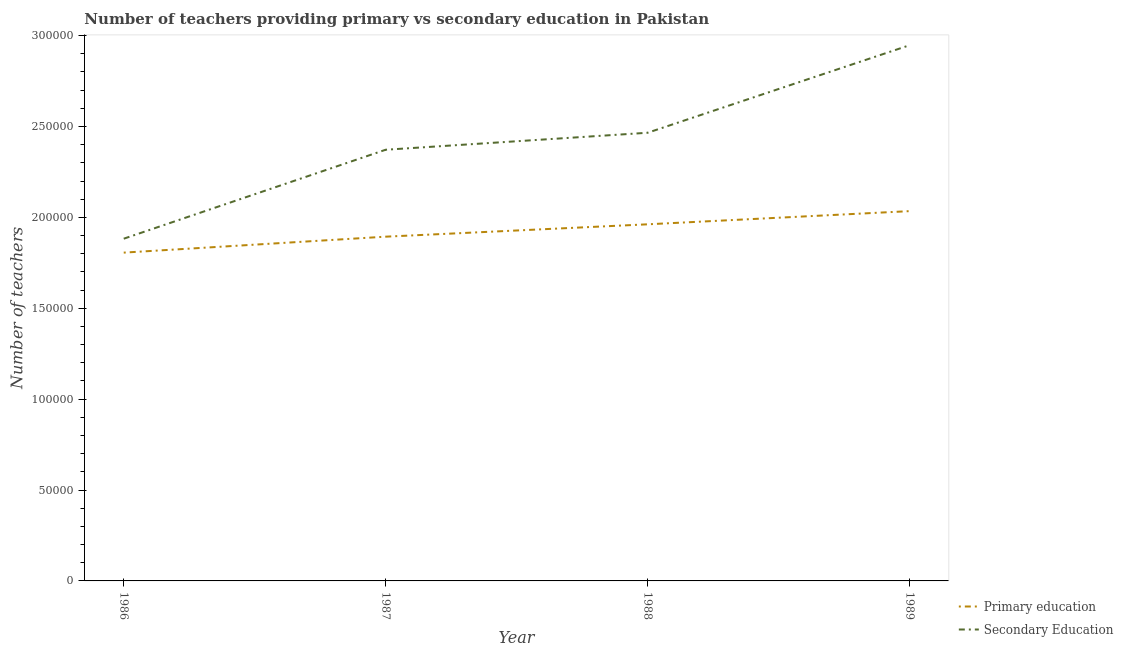What is the number of primary teachers in 1988?
Your answer should be very brief. 1.96e+05. Across all years, what is the maximum number of secondary teachers?
Your answer should be compact. 2.95e+05. Across all years, what is the minimum number of primary teachers?
Ensure brevity in your answer.  1.81e+05. In which year was the number of secondary teachers maximum?
Give a very brief answer. 1989. In which year was the number of primary teachers minimum?
Ensure brevity in your answer.  1986. What is the total number of primary teachers in the graph?
Ensure brevity in your answer.  7.70e+05. What is the difference between the number of primary teachers in 1986 and that in 1988?
Keep it short and to the point. -1.56e+04. What is the difference between the number of primary teachers in 1986 and the number of secondary teachers in 1988?
Your answer should be compact. -6.59e+04. What is the average number of primary teachers per year?
Provide a short and direct response. 1.92e+05. In the year 1986, what is the difference between the number of secondary teachers and number of primary teachers?
Your answer should be very brief. 7659. What is the ratio of the number of primary teachers in 1986 to that in 1989?
Ensure brevity in your answer.  0.89. Is the difference between the number of secondary teachers in 1987 and 1988 greater than the difference between the number of primary teachers in 1987 and 1988?
Offer a terse response. No. What is the difference between the highest and the second highest number of primary teachers?
Offer a very short reply. 7249. What is the difference between the highest and the lowest number of primary teachers?
Give a very brief answer. 2.28e+04. In how many years, is the number of primary teachers greater than the average number of primary teachers taken over all years?
Ensure brevity in your answer.  2. Is the sum of the number of primary teachers in 1986 and 1987 greater than the maximum number of secondary teachers across all years?
Your answer should be very brief. Yes. How many lines are there?
Offer a terse response. 2. What is the difference between two consecutive major ticks on the Y-axis?
Offer a very short reply. 5.00e+04. Are the values on the major ticks of Y-axis written in scientific E-notation?
Give a very brief answer. No. Where does the legend appear in the graph?
Make the answer very short. Bottom right. How many legend labels are there?
Your answer should be very brief. 2. How are the legend labels stacked?
Keep it short and to the point. Vertical. What is the title of the graph?
Give a very brief answer. Number of teachers providing primary vs secondary education in Pakistan. Does "Male labor force" appear as one of the legend labels in the graph?
Ensure brevity in your answer.  No. What is the label or title of the Y-axis?
Ensure brevity in your answer.  Number of teachers. What is the Number of teachers of Primary education in 1986?
Keep it short and to the point. 1.81e+05. What is the Number of teachers of Secondary Education in 1986?
Provide a short and direct response. 1.88e+05. What is the Number of teachers of Primary education in 1987?
Keep it short and to the point. 1.89e+05. What is the Number of teachers of Secondary Education in 1987?
Keep it short and to the point. 2.37e+05. What is the Number of teachers in Primary education in 1988?
Offer a terse response. 1.96e+05. What is the Number of teachers of Secondary Education in 1988?
Your answer should be compact. 2.47e+05. What is the Number of teachers of Primary education in 1989?
Provide a succinct answer. 2.03e+05. What is the Number of teachers in Secondary Education in 1989?
Keep it short and to the point. 2.95e+05. Across all years, what is the maximum Number of teachers of Primary education?
Provide a succinct answer. 2.03e+05. Across all years, what is the maximum Number of teachers of Secondary Education?
Offer a very short reply. 2.95e+05. Across all years, what is the minimum Number of teachers of Primary education?
Ensure brevity in your answer.  1.81e+05. Across all years, what is the minimum Number of teachers in Secondary Education?
Your answer should be compact. 1.88e+05. What is the total Number of teachers in Primary education in the graph?
Offer a very short reply. 7.70e+05. What is the total Number of teachers in Secondary Education in the graph?
Your response must be concise. 9.67e+05. What is the difference between the Number of teachers of Primary education in 1986 and that in 1987?
Provide a short and direct response. -8778. What is the difference between the Number of teachers of Secondary Education in 1986 and that in 1987?
Your answer should be compact. -4.89e+04. What is the difference between the Number of teachers in Primary education in 1986 and that in 1988?
Make the answer very short. -1.56e+04. What is the difference between the Number of teachers of Secondary Education in 1986 and that in 1988?
Provide a short and direct response. -5.83e+04. What is the difference between the Number of teachers in Primary education in 1986 and that in 1989?
Offer a very short reply. -2.28e+04. What is the difference between the Number of teachers in Secondary Education in 1986 and that in 1989?
Provide a succinct answer. -1.06e+05. What is the difference between the Number of teachers of Primary education in 1987 and that in 1988?
Offer a terse response. -6800. What is the difference between the Number of teachers in Secondary Education in 1987 and that in 1988?
Ensure brevity in your answer.  -9346. What is the difference between the Number of teachers of Primary education in 1987 and that in 1989?
Keep it short and to the point. -1.40e+04. What is the difference between the Number of teachers of Secondary Education in 1987 and that in 1989?
Offer a very short reply. -5.75e+04. What is the difference between the Number of teachers of Primary education in 1988 and that in 1989?
Offer a terse response. -7249. What is the difference between the Number of teachers in Secondary Education in 1988 and that in 1989?
Provide a short and direct response. -4.81e+04. What is the difference between the Number of teachers of Primary education in 1986 and the Number of teachers of Secondary Education in 1987?
Your response must be concise. -5.66e+04. What is the difference between the Number of teachers of Primary education in 1986 and the Number of teachers of Secondary Education in 1988?
Ensure brevity in your answer.  -6.59e+04. What is the difference between the Number of teachers of Primary education in 1986 and the Number of teachers of Secondary Education in 1989?
Give a very brief answer. -1.14e+05. What is the difference between the Number of teachers in Primary education in 1987 and the Number of teachers in Secondary Education in 1988?
Ensure brevity in your answer.  -5.72e+04. What is the difference between the Number of teachers in Primary education in 1987 and the Number of teachers in Secondary Education in 1989?
Keep it short and to the point. -1.05e+05. What is the difference between the Number of teachers of Primary education in 1988 and the Number of teachers of Secondary Education in 1989?
Provide a succinct answer. -9.85e+04. What is the average Number of teachers in Primary education per year?
Provide a succinct answer. 1.92e+05. What is the average Number of teachers of Secondary Education per year?
Keep it short and to the point. 2.42e+05. In the year 1986, what is the difference between the Number of teachers in Primary education and Number of teachers in Secondary Education?
Ensure brevity in your answer.  -7659. In the year 1987, what is the difference between the Number of teachers in Primary education and Number of teachers in Secondary Education?
Your answer should be compact. -4.78e+04. In the year 1988, what is the difference between the Number of teachers in Primary education and Number of teachers in Secondary Education?
Your answer should be compact. -5.04e+04. In the year 1989, what is the difference between the Number of teachers of Primary education and Number of teachers of Secondary Education?
Provide a short and direct response. -9.13e+04. What is the ratio of the Number of teachers of Primary education in 1986 to that in 1987?
Your answer should be very brief. 0.95. What is the ratio of the Number of teachers of Secondary Education in 1986 to that in 1987?
Give a very brief answer. 0.79. What is the ratio of the Number of teachers of Primary education in 1986 to that in 1988?
Your response must be concise. 0.92. What is the ratio of the Number of teachers in Secondary Education in 1986 to that in 1988?
Keep it short and to the point. 0.76. What is the ratio of the Number of teachers in Primary education in 1986 to that in 1989?
Provide a short and direct response. 0.89. What is the ratio of the Number of teachers of Secondary Education in 1986 to that in 1989?
Provide a succinct answer. 0.64. What is the ratio of the Number of teachers of Primary education in 1987 to that in 1988?
Give a very brief answer. 0.97. What is the ratio of the Number of teachers in Secondary Education in 1987 to that in 1988?
Provide a succinct answer. 0.96. What is the ratio of the Number of teachers of Primary education in 1987 to that in 1989?
Ensure brevity in your answer.  0.93. What is the ratio of the Number of teachers of Secondary Education in 1987 to that in 1989?
Offer a very short reply. 0.8. What is the ratio of the Number of teachers of Primary education in 1988 to that in 1989?
Your response must be concise. 0.96. What is the ratio of the Number of teachers of Secondary Education in 1988 to that in 1989?
Give a very brief answer. 0.84. What is the difference between the highest and the second highest Number of teachers of Primary education?
Ensure brevity in your answer.  7249. What is the difference between the highest and the second highest Number of teachers of Secondary Education?
Give a very brief answer. 4.81e+04. What is the difference between the highest and the lowest Number of teachers of Primary education?
Provide a succinct answer. 2.28e+04. What is the difference between the highest and the lowest Number of teachers in Secondary Education?
Your answer should be compact. 1.06e+05. 